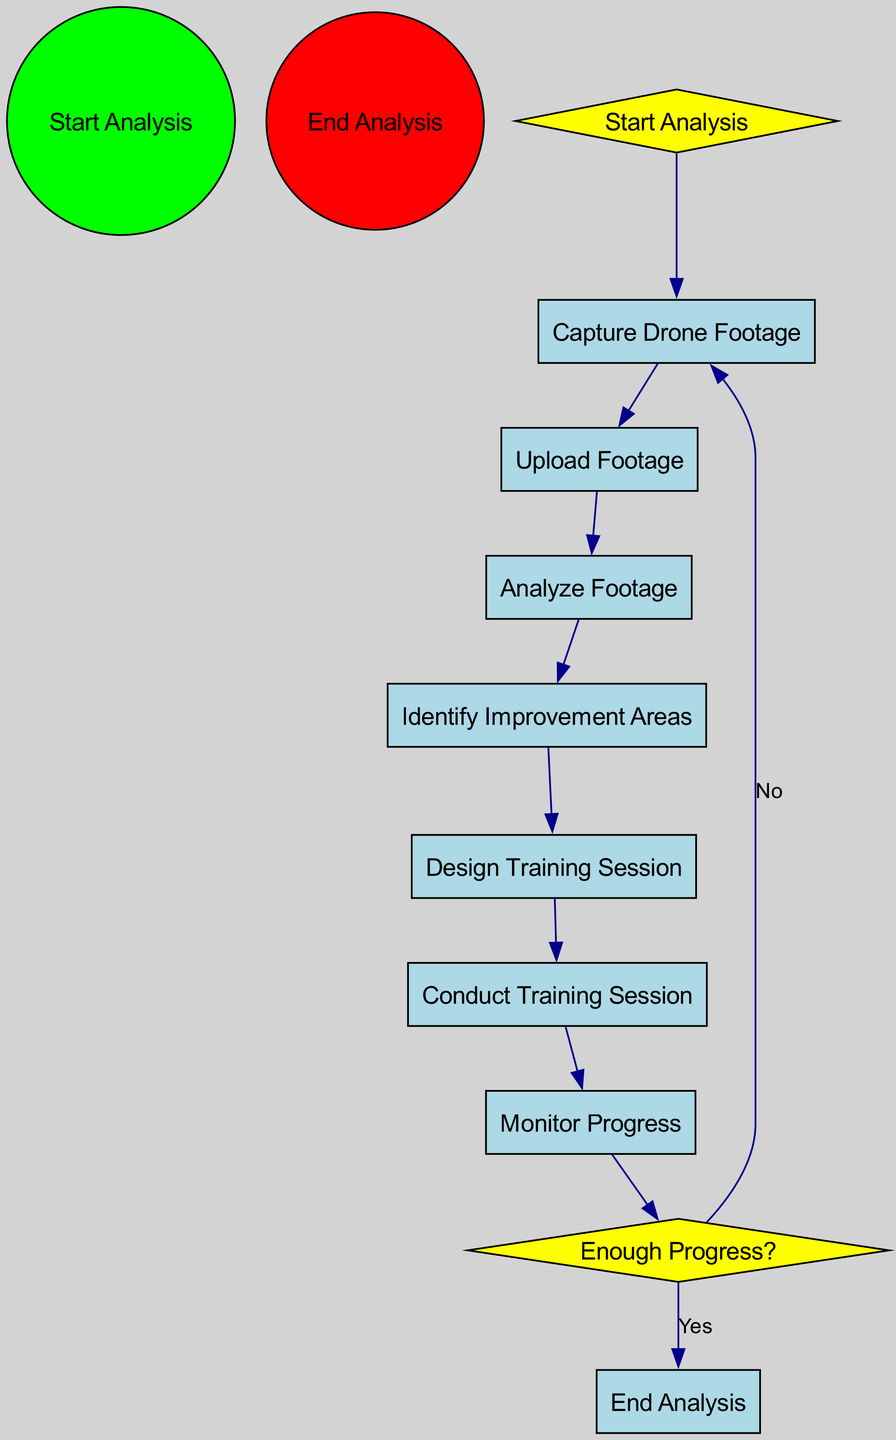What is the first action in the diagram? The diagram begins the flow with the "Start Analysis" event, leading directly to the first action, which is "Capture Drone Footage."
Answer: Capture Drone Footage How many actions are in the diagram? There are a total of eight actions listed in the diagram: Capture Drone Footage, Upload Footage, Analyze Footage, Identify Improvement Areas, Design Training Session, Conduct Training Session, Monitor Progress, and End Analysis.
Answer: Eight What decision point is presented in the diagram? The diagram contains one decision point labeled "Enough Progress?" which determines whether the team has made sufficient progress based on monitoring.
Answer: Enough Progress? What is the final action before concluding the analysis? The final action before concluding the analysis is "Monitor Progress," which involves observing players to assess their improvements after the conducted training sessions.
Answer: Monitor Progress What happens if there is not enough progress? If there is not enough progress, the flow returns to "Capture Drone Footage" to start the analysis process again, indicating that further improvements are needed before concluding the analysis.
Answer: Capture Drone Footage How are the actions connected in the diagram? The actions are connected sequentially, forming a linear flow: starting from "Capture Drone Footage" down to "Monitor Progress," with decisions branching from "Enough Progress?" leading to either ending the analysis or repeating the capture step.
Answer: Sequentially Which action follows the analysis of the footage? After analyzing the footage, the next action is to "Identify Improvement Areas," where specific areas for player and team strategy enhancements are identified based on the analyzed data.
Answer: Identify Improvement Areas What is the role of drone footage in this process? Drone footage serves as the crucial first input for the entire analysis process, allowing for comprehensive examination of player movements and strategies to inform subsequent training sessions.
Answer: Input for analysis 